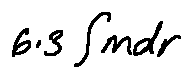<formula> <loc_0><loc_0><loc_500><loc_500>6 . 3 \int m d r</formula> 